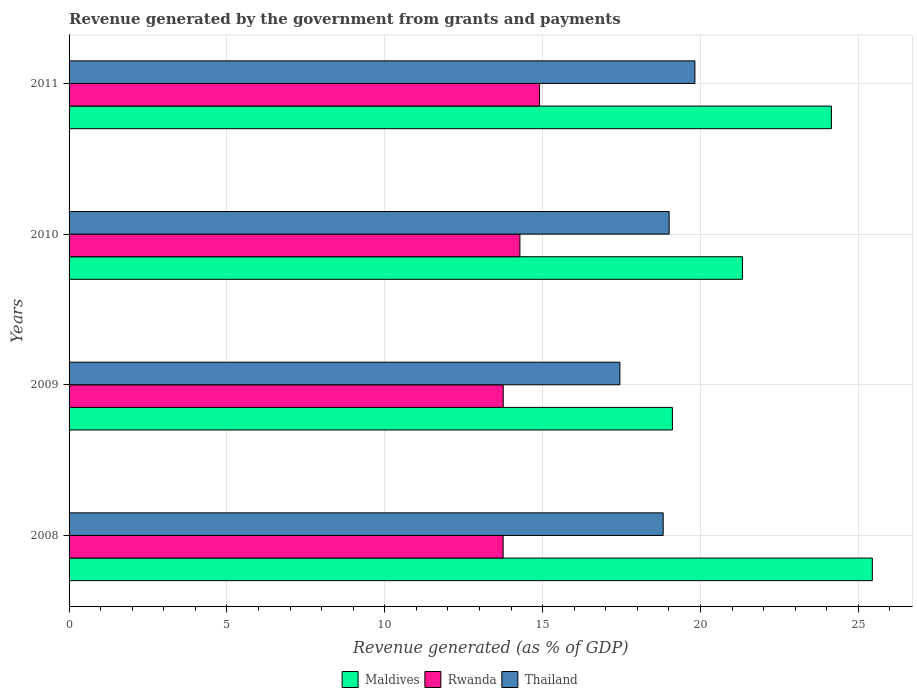What is the revenue generated by the government in Rwanda in 2009?
Offer a very short reply. 13.75. Across all years, what is the maximum revenue generated by the government in Thailand?
Keep it short and to the point. 19.82. Across all years, what is the minimum revenue generated by the government in Rwanda?
Your answer should be very brief. 13.75. In which year was the revenue generated by the government in Thailand maximum?
Keep it short and to the point. 2011. In which year was the revenue generated by the government in Maldives minimum?
Provide a short and direct response. 2009. What is the total revenue generated by the government in Rwanda in the graph?
Offer a terse response. 56.69. What is the difference between the revenue generated by the government in Maldives in 2009 and that in 2011?
Your answer should be very brief. -5.04. What is the difference between the revenue generated by the government in Thailand in 2010 and the revenue generated by the government in Rwanda in 2009?
Provide a short and direct response. 5.26. What is the average revenue generated by the government in Rwanda per year?
Keep it short and to the point. 14.17. In the year 2009, what is the difference between the revenue generated by the government in Rwanda and revenue generated by the government in Maldives?
Offer a terse response. -5.36. What is the ratio of the revenue generated by the government in Maldives in 2008 to that in 2010?
Your answer should be compact. 1.19. Is the revenue generated by the government in Rwanda in 2008 less than that in 2011?
Your answer should be compact. Yes. What is the difference between the highest and the second highest revenue generated by the government in Thailand?
Provide a short and direct response. 0.82. What is the difference between the highest and the lowest revenue generated by the government in Thailand?
Provide a short and direct response. 2.38. In how many years, is the revenue generated by the government in Maldives greater than the average revenue generated by the government in Maldives taken over all years?
Give a very brief answer. 2. Is the sum of the revenue generated by the government in Maldives in 2008 and 2010 greater than the maximum revenue generated by the government in Rwanda across all years?
Provide a short and direct response. Yes. What does the 1st bar from the top in 2011 represents?
Offer a very short reply. Thailand. What does the 3rd bar from the bottom in 2011 represents?
Provide a short and direct response. Thailand. Are all the bars in the graph horizontal?
Your answer should be compact. Yes. How many years are there in the graph?
Keep it short and to the point. 4. Does the graph contain any zero values?
Your answer should be compact. No. Where does the legend appear in the graph?
Provide a succinct answer. Bottom center. How many legend labels are there?
Offer a terse response. 3. What is the title of the graph?
Give a very brief answer. Revenue generated by the government from grants and payments. What is the label or title of the X-axis?
Your answer should be very brief. Revenue generated (as % of GDP). What is the Revenue generated (as % of GDP) in Maldives in 2008?
Your response must be concise. 25.44. What is the Revenue generated (as % of GDP) in Rwanda in 2008?
Your answer should be very brief. 13.75. What is the Revenue generated (as % of GDP) in Thailand in 2008?
Give a very brief answer. 18.82. What is the Revenue generated (as % of GDP) in Maldives in 2009?
Ensure brevity in your answer.  19.11. What is the Revenue generated (as % of GDP) in Rwanda in 2009?
Your answer should be very brief. 13.75. What is the Revenue generated (as % of GDP) in Thailand in 2009?
Your response must be concise. 17.45. What is the Revenue generated (as % of GDP) of Maldives in 2010?
Offer a very short reply. 21.33. What is the Revenue generated (as % of GDP) of Rwanda in 2010?
Keep it short and to the point. 14.28. What is the Revenue generated (as % of GDP) of Thailand in 2010?
Provide a short and direct response. 19.01. What is the Revenue generated (as % of GDP) in Maldives in 2011?
Offer a very short reply. 24.15. What is the Revenue generated (as % of GDP) in Rwanda in 2011?
Offer a terse response. 14.9. What is the Revenue generated (as % of GDP) in Thailand in 2011?
Give a very brief answer. 19.82. Across all years, what is the maximum Revenue generated (as % of GDP) in Maldives?
Offer a terse response. 25.44. Across all years, what is the maximum Revenue generated (as % of GDP) in Rwanda?
Provide a short and direct response. 14.9. Across all years, what is the maximum Revenue generated (as % of GDP) of Thailand?
Ensure brevity in your answer.  19.82. Across all years, what is the minimum Revenue generated (as % of GDP) in Maldives?
Provide a succinct answer. 19.11. Across all years, what is the minimum Revenue generated (as % of GDP) of Rwanda?
Your answer should be very brief. 13.75. Across all years, what is the minimum Revenue generated (as % of GDP) of Thailand?
Offer a very short reply. 17.45. What is the total Revenue generated (as % of GDP) in Maldives in the graph?
Keep it short and to the point. 90.03. What is the total Revenue generated (as % of GDP) in Rwanda in the graph?
Offer a very short reply. 56.69. What is the total Revenue generated (as % of GDP) of Thailand in the graph?
Provide a short and direct response. 75.1. What is the difference between the Revenue generated (as % of GDP) in Maldives in 2008 and that in 2009?
Make the answer very short. 6.33. What is the difference between the Revenue generated (as % of GDP) in Rwanda in 2008 and that in 2009?
Keep it short and to the point. -0. What is the difference between the Revenue generated (as % of GDP) in Thailand in 2008 and that in 2009?
Offer a terse response. 1.37. What is the difference between the Revenue generated (as % of GDP) of Maldives in 2008 and that in 2010?
Offer a terse response. 4.12. What is the difference between the Revenue generated (as % of GDP) in Rwanda in 2008 and that in 2010?
Offer a very short reply. -0.53. What is the difference between the Revenue generated (as % of GDP) of Thailand in 2008 and that in 2010?
Your answer should be very brief. -0.19. What is the difference between the Revenue generated (as % of GDP) in Maldives in 2008 and that in 2011?
Offer a very short reply. 1.3. What is the difference between the Revenue generated (as % of GDP) of Rwanda in 2008 and that in 2011?
Provide a short and direct response. -1.15. What is the difference between the Revenue generated (as % of GDP) of Thailand in 2008 and that in 2011?
Your response must be concise. -1.01. What is the difference between the Revenue generated (as % of GDP) in Maldives in 2009 and that in 2010?
Give a very brief answer. -2.22. What is the difference between the Revenue generated (as % of GDP) in Rwanda in 2009 and that in 2010?
Make the answer very short. -0.53. What is the difference between the Revenue generated (as % of GDP) of Thailand in 2009 and that in 2010?
Your response must be concise. -1.56. What is the difference between the Revenue generated (as % of GDP) of Maldives in 2009 and that in 2011?
Your response must be concise. -5.04. What is the difference between the Revenue generated (as % of GDP) of Rwanda in 2009 and that in 2011?
Your answer should be very brief. -1.15. What is the difference between the Revenue generated (as % of GDP) of Thailand in 2009 and that in 2011?
Provide a short and direct response. -2.38. What is the difference between the Revenue generated (as % of GDP) in Maldives in 2010 and that in 2011?
Keep it short and to the point. -2.82. What is the difference between the Revenue generated (as % of GDP) in Rwanda in 2010 and that in 2011?
Provide a short and direct response. -0.62. What is the difference between the Revenue generated (as % of GDP) in Thailand in 2010 and that in 2011?
Make the answer very short. -0.82. What is the difference between the Revenue generated (as % of GDP) of Maldives in 2008 and the Revenue generated (as % of GDP) of Rwanda in 2009?
Offer a very short reply. 11.69. What is the difference between the Revenue generated (as % of GDP) of Maldives in 2008 and the Revenue generated (as % of GDP) of Thailand in 2009?
Give a very brief answer. 8. What is the difference between the Revenue generated (as % of GDP) in Rwanda in 2008 and the Revenue generated (as % of GDP) in Thailand in 2009?
Keep it short and to the point. -3.7. What is the difference between the Revenue generated (as % of GDP) of Maldives in 2008 and the Revenue generated (as % of GDP) of Rwanda in 2010?
Your answer should be compact. 11.16. What is the difference between the Revenue generated (as % of GDP) in Maldives in 2008 and the Revenue generated (as % of GDP) in Thailand in 2010?
Give a very brief answer. 6.44. What is the difference between the Revenue generated (as % of GDP) of Rwanda in 2008 and the Revenue generated (as % of GDP) of Thailand in 2010?
Your answer should be very brief. -5.26. What is the difference between the Revenue generated (as % of GDP) of Maldives in 2008 and the Revenue generated (as % of GDP) of Rwanda in 2011?
Ensure brevity in your answer.  10.54. What is the difference between the Revenue generated (as % of GDP) of Maldives in 2008 and the Revenue generated (as % of GDP) of Thailand in 2011?
Offer a very short reply. 5.62. What is the difference between the Revenue generated (as % of GDP) of Rwanda in 2008 and the Revenue generated (as % of GDP) of Thailand in 2011?
Give a very brief answer. -6.07. What is the difference between the Revenue generated (as % of GDP) in Maldives in 2009 and the Revenue generated (as % of GDP) in Rwanda in 2010?
Provide a short and direct response. 4.83. What is the difference between the Revenue generated (as % of GDP) in Maldives in 2009 and the Revenue generated (as % of GDP) in Thailand in 2010?
Give a very brief answer. 0.1. What is the difference between the Revenue generated (as % of GDP) in Rwanda in 2009 and the Revenue generated (as % of GDP) in Thailand in 2010?
Your response must be concise. -5.26. What is the difference between the Revenue generated (as % of GDP) in Maldives in 2009 and the Revenue generated (as % of GDP) in Rwanda in 2011?
Give a very brief answer. 4.21. What is the difference between the Revenue generated (as % of GDP) of Maldives in 2009 and the Revenue generated (as % of GDP) of Thailand in 2011?
Your answer should be compact. -0.71. What is the difference between the Revenue generated (as % of GDP) of Rwanda in 2009 and the Revenue generated (as % of GDP) of Thailand in 2011?
Offer a very short reply. -6.07. What is the difference between the Revenue generated (as % of GDP) of Maldives in 2010 and the Revenue generated (as % of GDP) of Rwanda in 2011?
Make the answer very short. 6.42. What is the difference between the Revenue generated (as % of GDP) of Maldives in 2010 and the Revenue generated (as % of GDP) of Thailand in 2011?
Offer a terse response. 1.51. What is the difference between the Revenue generated (as % of GDP) in Rwanda in 2010 and the Revenue generated (as % of GDP) in Thailand in 2011?
Provide a short and direct response. -5.54. What is the average Revenue generated (as % of GDP) in Maldives per year?
Offer a terse response. 22.51. What is the average Revenue generated (as % of GDP) of Rwanda per year?
Ensure brevity in your answer.  14.17. What is the average Revenue generated (as % of GDP) in Thailand per year?
Give a very brief answer. 18.77. In the year 2008, what is the difference between the Revenue generated (as % of GDP) of Maldives and Revenue generated (as % of GDP) of Rwanda?
Your response must be concise. 11.69. In the year 2008, what is the difference between the Revenue generated (as % of GDP) of Maldives and Revenue generated (as % of GDP) of Thailand?
Provide a short and direct response. 6.63. In the year 2008, what is the difference between the Revenue generated (as % of GDP) of Rwanda and Revenue generated (as % of GDP) of Thailand?
Make the answer very short. -5.07. In the year 2009, what is the difference between the Revenue generated (as % of GDP) of Maldives and Revenue generated (as % of GDP) of Rwanda?
Your answer should be compact. 5.36. In the year 2009, what is the difference between the Revenue generated (as % of GDP) in Maldives and Revenue generated (as % of GDP) in Thailand?
Your answer should be very brief. 1.66. In the year 2009, what is the difference between the Revenue generated (as % of GDP) in Rwanda and Revenue generated (as % of GDP) in Thailand?
Keep it short and to the point. -3.7. In the year 2010, what is the difference between the Revenue generated (as % of GDP) of Maldives and Revenue generated (as % of GDP) of Rwanda?
Offer a terse response. 7.05. In the year 2010, what is the difference between the Revenue generated (as % of GDP) in Maldives and Revenue generated (as % of GDP) in Thailand?
Provide a short and direct response. 2.32. In the year 2010, what is the difference between the Revenue generated (as % of GDP) in Rwanda and Revenue generated (as % of GDP) in Thailand?
Keep it short and to the point. -4.73. In the year 2011, what is the difference between the Revenue generated (as % of GDP) of Maldives and Revenue generated (as % of GDP) of Rwanda?
Your answer should be compact. 9.24. In the year 2011, what is the difference between the Revenue generated (as % of GDP) in Maldives and Revenue generated (as % of GDP) in Thailand?
Ensure brevity in your answer.  4.33. In the year 2011, what is the difference between the Revenue generated (as % of GDP) of Rwanda and Revenue generated (as % of GDP) of Thailand?
Provide a short and direct response. -4.92. What is the ratio of the Revenue generated (as % of GDP) in Maldives in 2008 to that in 2009?
Provide a short and direct response. 1.33. What is the ratio of the Revenue generated (as % of GDP) in Thailand in 2008 to that in 2009?
Make the answer very short. 1.08. What is the ratio of the Revenue generated (as % of GDP) in Maldives in 2008 to that in 2010?
Provide a succinct answer. 1.19. What is the ratio of the Revenue generated (as % of GDP) of Rwanda in 2008 to that in 2010?
Offer a very short reply. 0.96. What is the ratio of the Revenue generated (as % of GDP) in Thailand in 2008 to that in 2010?
Provide a short and direct response. 0.99. What is the ratio of the Revenue generated (as % of GDP) of Maldives in 2008 to that in 2011?
Keep it short and to the point. 1.05. What is the ratio of the Revenue generated (as % of GDP) in Rwanda in 2008 to that in 2011?
Your answer should be compact. 0.92. What is the ratio of the Revenue generated (as % of GDP) in Thailand in 2008 to that in 2011?
Offer a terse response. 0.95. What is the ratio of the Revenue generated (as % of GDP) in Maldives in 2009 to that in 2010?
Keep it short and to the point. 0.9. What is the ratio of the Revenue generated (as % of GDP) in Rwanda in 2009 to that in 2010?
Provide a short and direct response. 0.96. What is the ratio of the Revenue generated (as % of GDP) in Thailand in 2009 to that in 2010?
Your answer should be very brief. 0.92. What is the ratio of the Revenue generated (as % of GDP) in Maldives in 2009 to that in 2011?
Offer a very short reply. 0.79. What is the ratio of the Revenue generated (as % of GDP) of Rwanda in 2009 to that in 2011?
Keep it short and to the point. 0.92. What is the ratio of the Revenue generated (as % of GDP) in Thailand in 2009 to that in 2011?
Your answer should be compact. 0.88. What is the ratio of the Revenue generated (as % of GDP) of Maldives in 2010 to that in 2011?
Your answer should be compact. 0.88. What is the ratio of the Revenue generated (as % of GDP) of Rwanda in 2010 to that in 2011?
Offer a terse response. 0.96. What is the ratio of the Revenue generated (as % of GDP) of Thailand in 2010 to that in 2011?
Your answer should be very brief. 0.96. What is the difference between the highest and the second highest Revenue generated (as % of GDP) of Maldives?
Ensure brevity in your answer.  1.3. What is the difference between the highest and the second highest Revenue generated (as % of GDP) of Rwanda?
Make the answer very short. 0.62. What is the difference between the highest and the second highest Revenue generated (as % of GDP) in Thailand?
Keep it short and to the point. 0.82. What is the difference between the highest and the lowest Revenue generated (as % of GDP) in Maldives?
Offer a very short reply. 6.33. What is the difference between the highest and the lowest Revenue generated (as % of GDP) in Rwanda?
Ensure brevity in your answer.  1.15. What is the difference between the highest and the lowest Revenue generated (as % of GDP) in Thailand?
Make the answer very short. 2.38. 